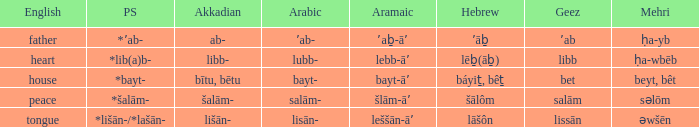If in English it's house, what is it in proto-semitic? *bayt-. 